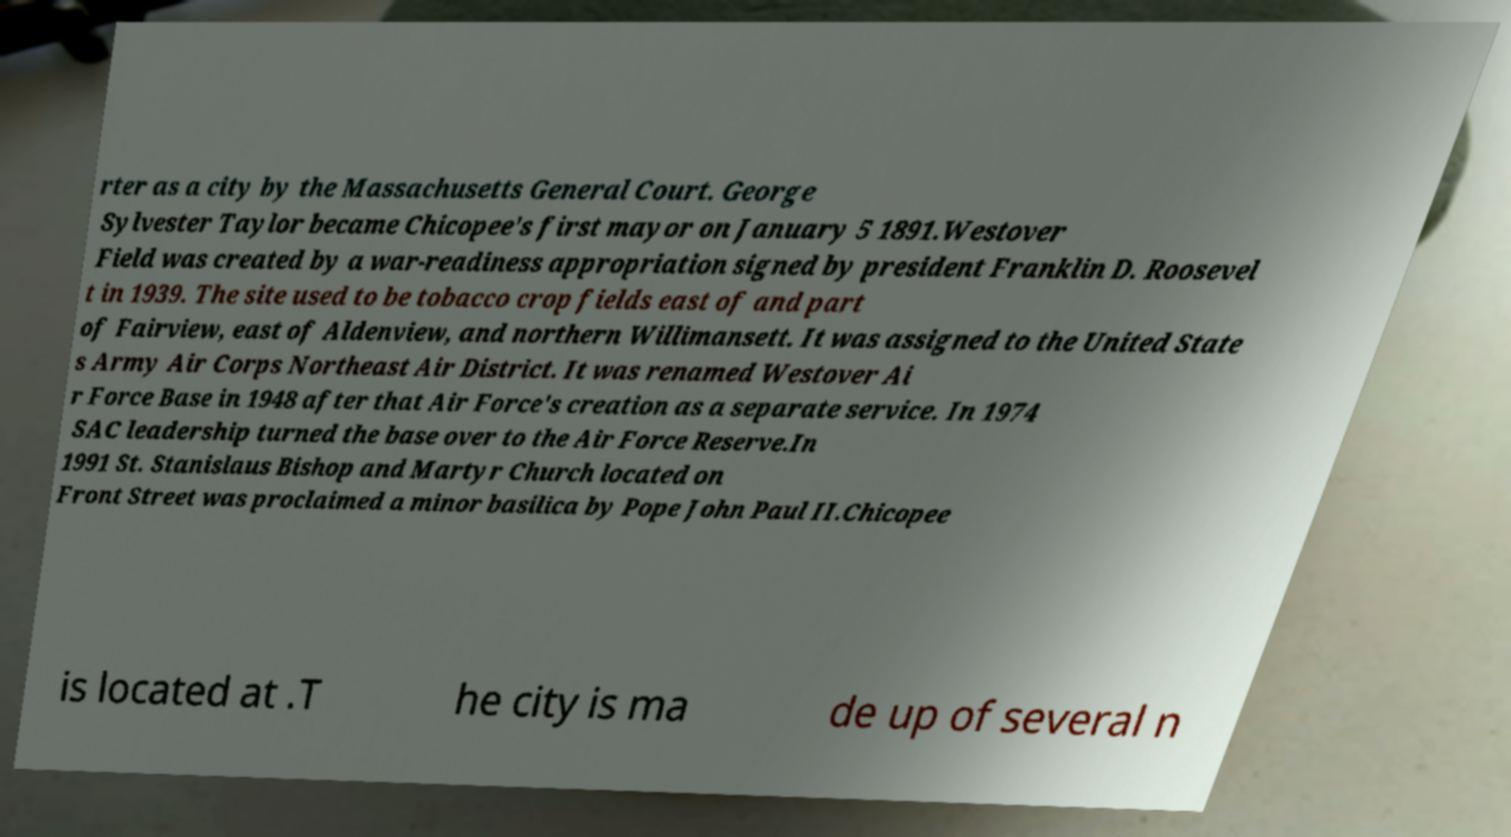I need the written content from this picture converted into text. Can you do that? rter as a city by the Massachusetts General Court. George Sylvester Taylor became Chicopee's first mayor on January 5 1891.Westover Field was created by a war-readiness appropriation signed by president Franklin D. Roosevel t in 1939. The site used to be tobacco crop fields east of and part of Fairview, east of Aldenview, and northern Willimansett. It was assigned to the United State s Army Air Corps Northeast Air District. It was renamed Westover Ai r Force Base in 1948 after that Air Force's creation as a separate service. In 1974 SAC leadership turned the base over to the Air Force Reserve.In 1991 St. Stanislaus Bishop and Martyr Church located on Front Street was proclaimed a minor basilica by Pope John Paul II.Chicopee is located at .T he city is ma de up of several n 